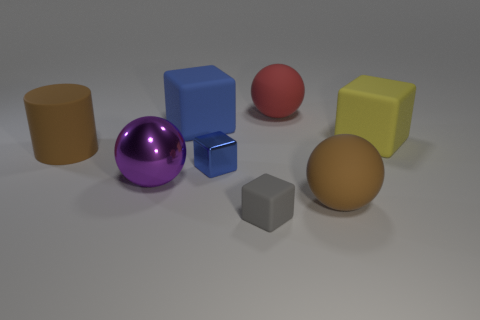What number of large things are blue cubes or yellow things?
Your response must be concise. 2. How many blocks are behind the big yellow matte block and in front of the tiny metal block?
Keep it short and to the point. 0. Does the big yellow block have the same material as the small object that is in front of the big purple object?
Provide a succinct answer. Yes. How many blue objects are tiny blocks or spheres?
Give a very brief answer. 1. Are there any other brown balls of the same size as the brown rubber sphere?
Your response must be concise. No. What material is the brown thing on the left side of the large block on the left side of the matte cube that is to the right of the big red object?
Make the answer very short. Rubber. Is the number of blue metal things that are in front of the small matte block the same as the number of green metal blocks?
Your response must be concise. Yes. Do the big brown object behind the metallic block and the blue block in front of the big cylinder have the same material?
Offer a terse response. No. How many things are purple shiny objects or big rubber things that are on the right side of the large rubber cylinder?
Your response must be concise. 5. Is there a large red rubber thing that has the same shape as the large blue matte thing?
Give a very brief answer. No. 